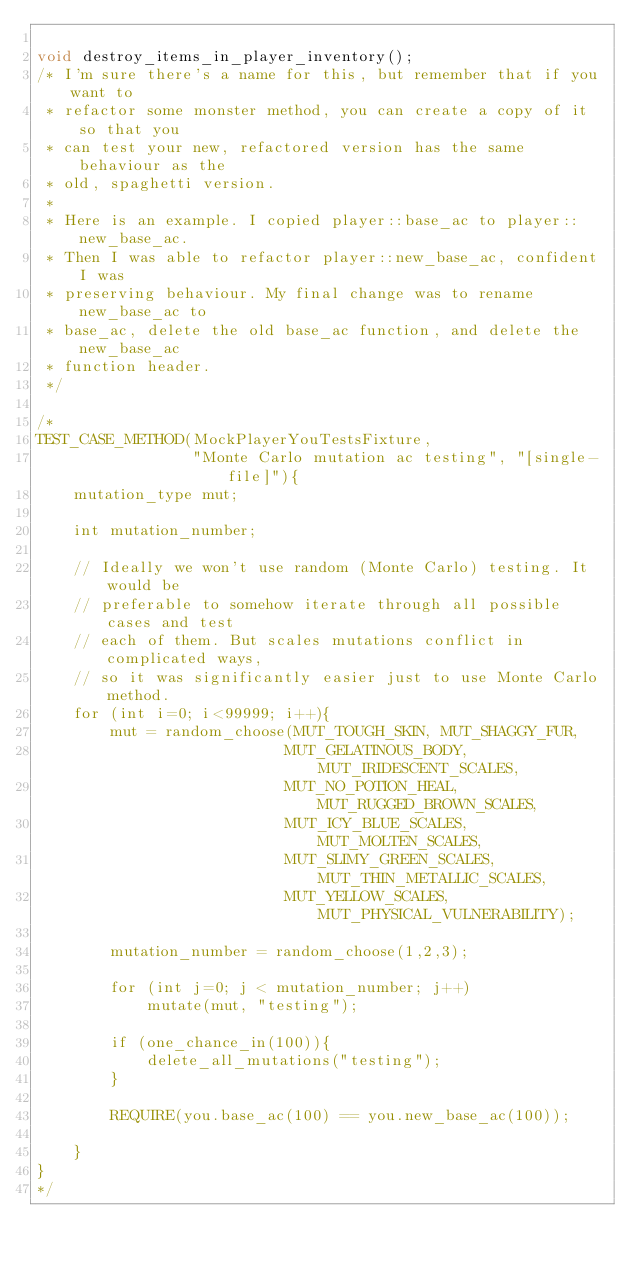<code> <loc_0><loc_0><loc_500><loc_500><_C_>
void destroy_items_in_player_inventory();
/* I'm sure there's a name for this, but remember that if you want to
 * refactor some monster method, you can create a copy of it so that you
 * can test your new, refactored version has the same behaviour as the
 * old, spaghetti version.
 *
 * Here is an example. I copied player::base_ac to player::new_base_ac.
 * Then I was able to refactor player::new_base_ac, confident I was
 * preserving behaviour. My final change was to rename new_base_ac to
 * base_ac, delete the old base_ac function, and delete the new_base_ac
 * function header.
 */

/*
TEST_CASE_METHOD(MockPlayerYouTestsFixture,
                 "Monte Carlo mutation ac testing", "[single-file]"){
    mutation_type mut;

    int mutation_number;

    // Ideally we won't use random (Monte Carlo) testing. It would be
    // preferable to somehow iterate through all possible cases and test
    // each of them. But scales mutations conflict in complicated ways,
    // so it was significantly easier just to use Monte Carlo method.
    for (int i=0; i<99999; i++){
        mut = random_choose(MUT_TOUGH_SKIN, MUT_SHAGGY_FUR,
                           MUT_GELATINOUS_BODY, MUT_IRIDESCENT_SCALES,
                           MUT_NO_POTION_HEAL, MUT_RUGGED_BROWN_SCALES,
                           MUT_ICY_BLUE_SCALES, MUT_MOLTEN_SCALES,
                           MUT_SLIMY_GREEN_SCALES, MUT_THIN_METALLIC_SCALES,
                           MUT_YELLOW_SCALES, MUT_PHYSICAL_VULNERABILITY);

        mutation_number = random_choose(1,2,3);

        for (int j=0; j < mutation_number; j++)
            mutate(mut, "testing");

        if (one_chance_in(100)){
            delete_all_mutations("testing");
        }

        REQUIRE(you.base_ac(100) == you.new_base_ac(100));

    }
}
*/
</code> 